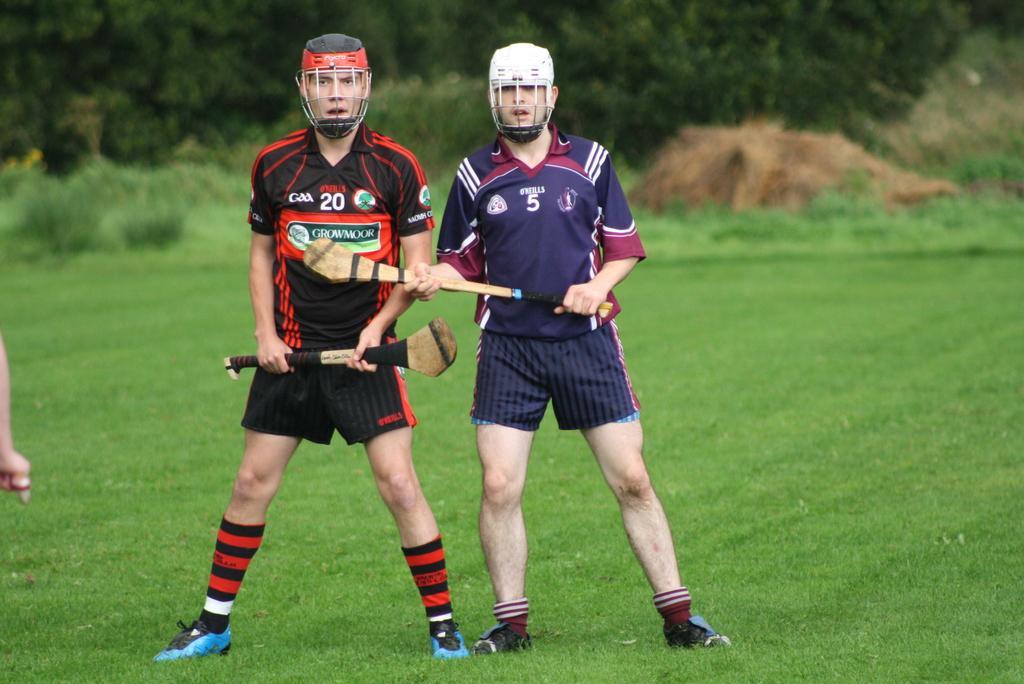Describe this image in one or two sentences. In this picture, we see two men in black T-shirt and in blue T-shirt who are wearing helmets are holding the wooden sticks in their hands. At the bottom of the picture, we see grass. In the background, there are many trees. 